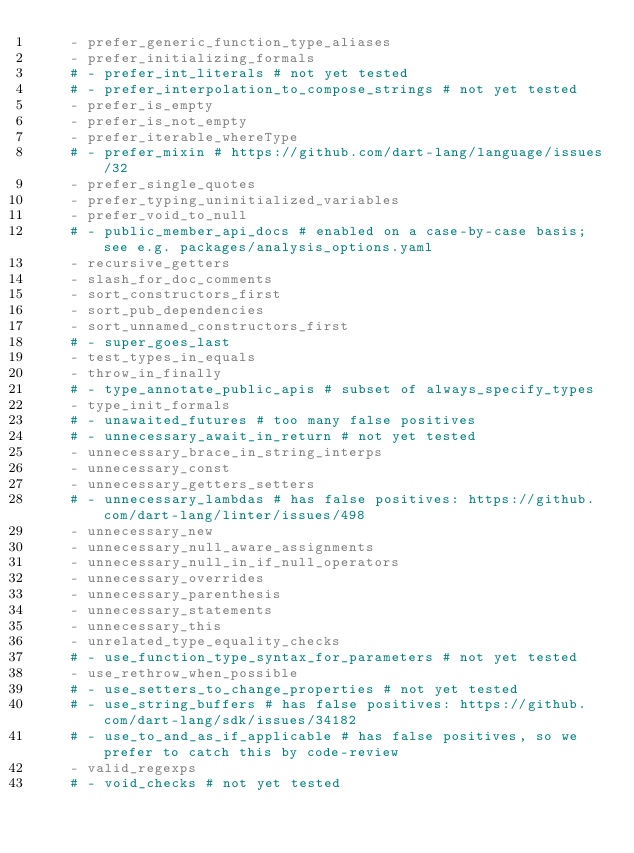<code> <loc_0><loc_0><loc_500><loc_500><_YAML_>    - prefer_generic_function_type_aliases
    - prefer_initializing_formals
    # - prefer_int_literals # not yet tested
    # - prefer_interpolation_to_compose_strings # not yet tested
    - prefer_is_empty
    - prefer_is_not_empty
    - prefer_iterable_whereType
    # - prefer_mixin # https://github.com/dart-lang/language/issues/32
    - prefer_single_quotes
    - prefer_typing_uninitialized_variables
    - prefer_void_to_null
    # - public_member_api_docs # enabled on a case-by-case basis; see e.g. packages/analysis_options.yaml
    - recursive_getters
    - slash_for_doc_comments
    - sort_constructors_first
    - sort_pub_dependencies
    - sort_unnamed_constructors_first
    # - super_goes_last
    - test_types_in_equals
    - throw_in_finally
    # - type_annotate_public_apis # subset of always_specify_types
    - type_init_formals
    # - unawaited_futures # too many false positives
    # - unnecessary_await_in_return # not yet tested
    - unnecessary_brace_in_string_interps
    - unnecessary_const
    - unnecessary_getters_setters
    # - unnecessary_lambdas # has false positives: https://github.com/dart-lang/linter/issues/498
    - unnecessary_new
    - unnecessary_null_aware_assignments
    - unnecessary_null_in_if_null_operators
    - unnecessary_overrides
    - unnecessary_parenthesis
    - unnecessary_statements
    - unnecessary_this
    - unrelated_type_equality_checks
    # - use_function_type_syntax_for_parameters # not yet tested
    - use_rethrow_when_possible
    # - use_setters_to_change_properties # not yet tested
    # - use_string_buffers # has false positives: https://github.com/dart-lang/sdk/issues/34182
    # - use_to_and_as_if_applicable # has false positives, so we prefer to catch this by code-review
    - valid_regexps
    # - void_checks # not yet tested
</code> 